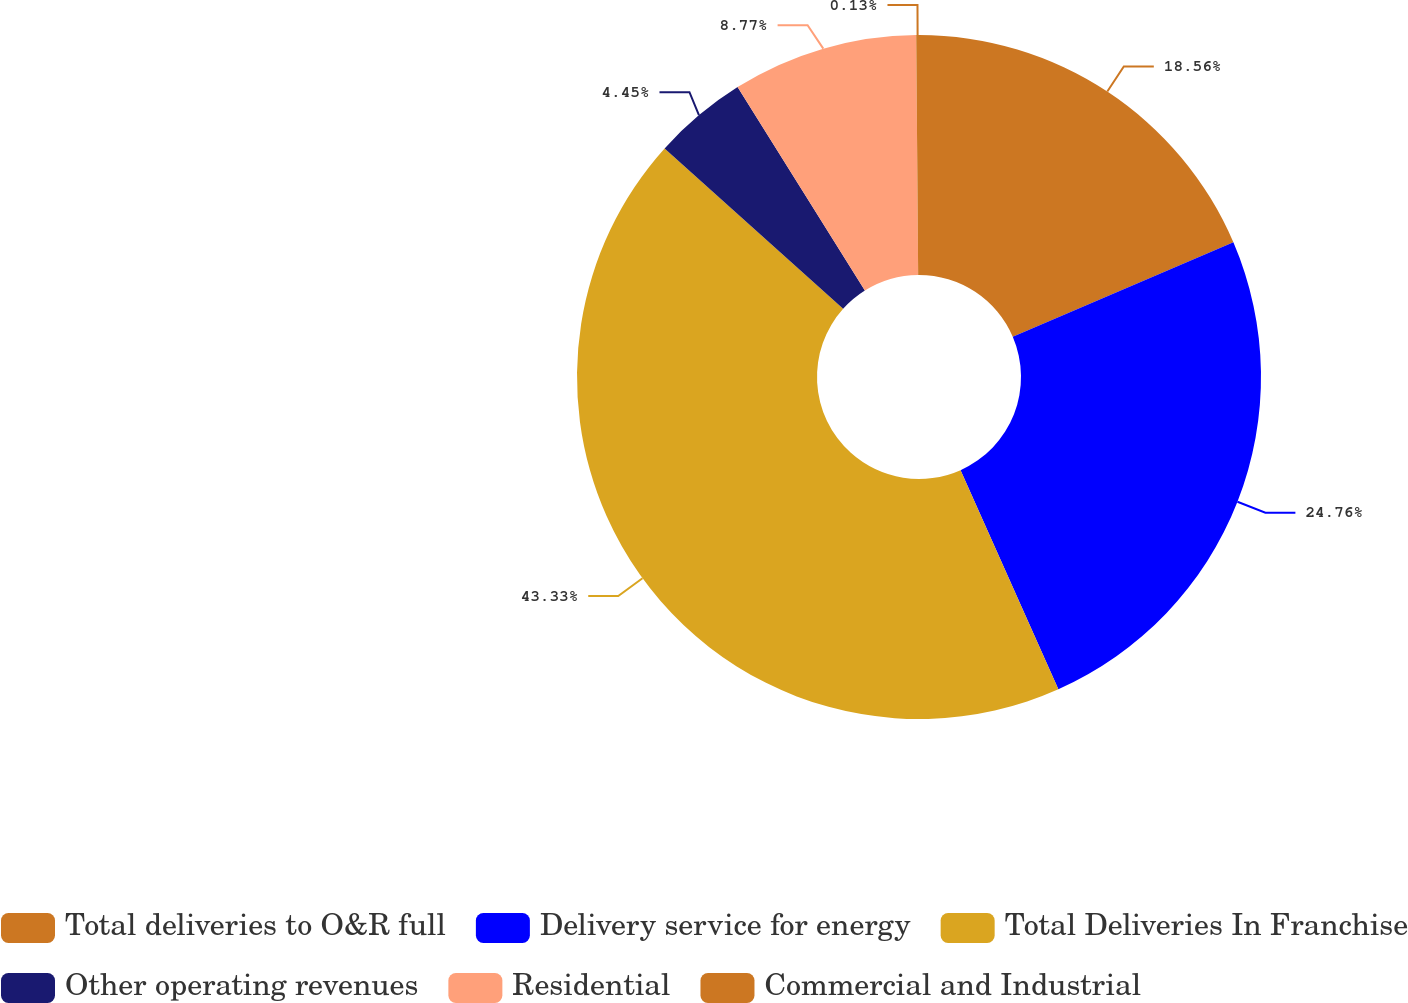<chart> <loc_0><loc_0><loc_500><loc_500><pie_chart><fcel>Total deliveries to O&R full<fcel>Delivery service for energy<fcel>Total Deliveries In Franchise<fcel>Other operating revenues<fcel>Residential<fcel>Commercial and Industrial<nl><fcel>18.56%<fcel>24.76%<fcel>43.33%<fcel>4.45%<fcel>8.77%<fcel>0.13%<nl></chart> 